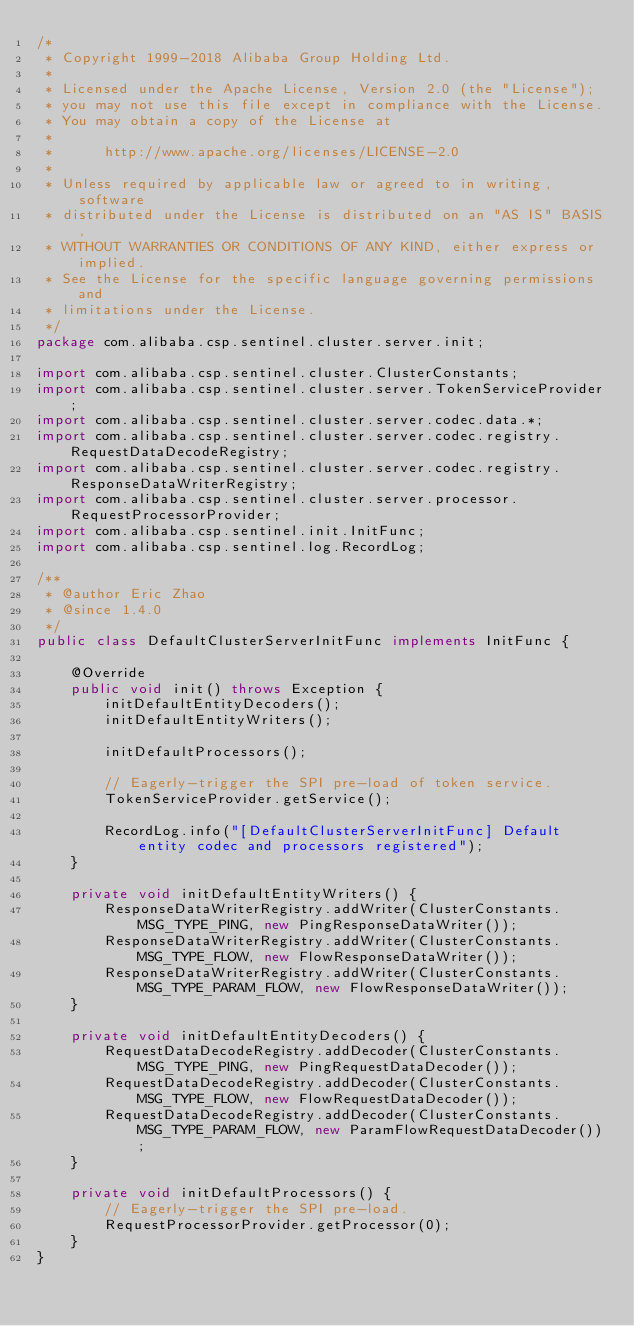Convert code to text. <code><loc_0><loc_0><loc_500><loc_500><_Java_>/*
 * Copyright 1999-2018 Alibaba Group Holding Ltd.
 *
 * Licensed under the Apache License, Version 2.0 (the "License");
 * you may not use this file except in compliance with the License.
 * You may obtain a copy of the License at
 *
 *      http://www.apache.org/licenses/LICENSE-2.0
 *
 * Unless required by applicable law or agreed to in writing, software
 * distributed under the License is distributed on an "AS IS" BASIS,
 * WITHOUT WARRANTIES OR CONDITIONS OF ANY KIND, either express or implied.
 * See the License for the specific language governing permissions and
 * limitations under the License.
 */
package com.alibaba.csp.sentinel.cluster.server.init;

import com.alibaba.csp.sentinel.cluster.ClusterConstants;
import com.alibaba.csp.sentinel.cluster.server.TokenServiceProvider;
import com.alibaba.csp.sentinel.cluster.server.codec.data.*;
import com.alibaba.csp.sentinel.cluster.server.codec.registry.RequestDataDecodeRegistry;
import com.alibaba.csp.sentinel.cluster.server.codec.registry.ResponseDataWriterRegistry;
import com.alibaba.csp.sentinel.cluster.server.processor.RequestProcessorProvider;
import com.alibaba.csp.sentinel.init.InitFunc;
import com.alibaba.csp.sentinel.log.RecordLog;

/**
 * @author Eric Zhao
 * @since 1.4.0
 */
public class DefaultClusterServerInitFunc implements InitFunc {

    @Override
    public void init() throws Exception {
        initDefaultEntityDecoders();
        initDefaultEntityWriters();

        initDefaultProcessors();

        // Eagerly-trigger the SPI pre-load of token service.
        TokenServiceProvider.getService();

        RecordLog.info("[DefaultClusterServerInitFunc] Default entity codec and processors registered");
    }

    private void initDefaultEntityWriters() {
        ResponseDataWriterRegistry.addWriter(ClusterConstants.MSG_TYPE_PING, new PingResponseDataWriter());
        ResponseDataWriterRegistry.addWriter(ClusterConstants.MSG_TYPE_FLOW, new FlowResponseDataWriter());
        ResponseDataWriterRegistry.addWriter(ClusterConstants.MSG_TYPE_PARAM_FLOW, new FlowResponseDataWriter());
    }

    private void initDefaultEntityDecoders() {
        RequestDataDecodeRegistry.addDecoder(ClusterConstants.MSG_TYPE_PING, new PingRequestDataDecoder());
        RequestDataDecodeRegistry.addDecoder(ClusterConstants.MSG_TYPE_FLOW, new FlowRequestDataDecoder());
        RequestDataDecodeRegistry.addDecoder(ClusterConstants.MSG_TYPE_PARAM_FLOW, new ParamFlowRequestDataDecoder());
    }

    private void initDefaultProcessors() {
        // Eagerly-trigger the SPI pre-load.
        RequestProcessorProvider.getProcessor(0);
    }
}
</code> 